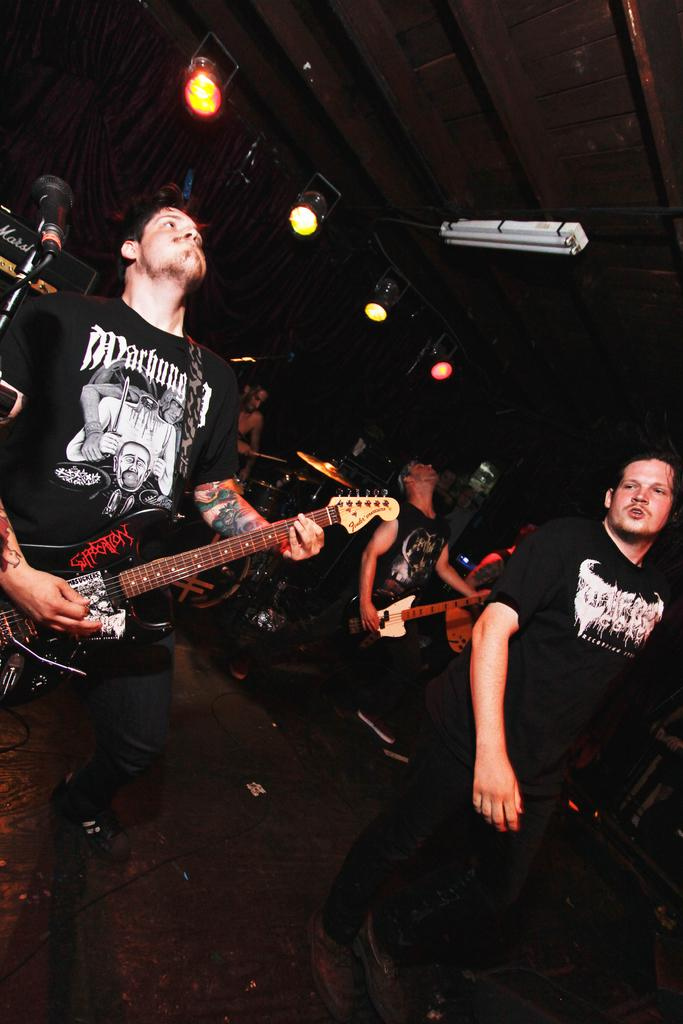What are the people in the image doing? The people in the image are playing musical instruments. Can you describe the background of the image? There are lights visible in the background of the image. What type of secretary can be seen working in the image? There is no secretary present in the image; it features people playing musical instruments. How many ladybugs are visible on the musical instruments in the image? There are no ladybugs present in the image. 